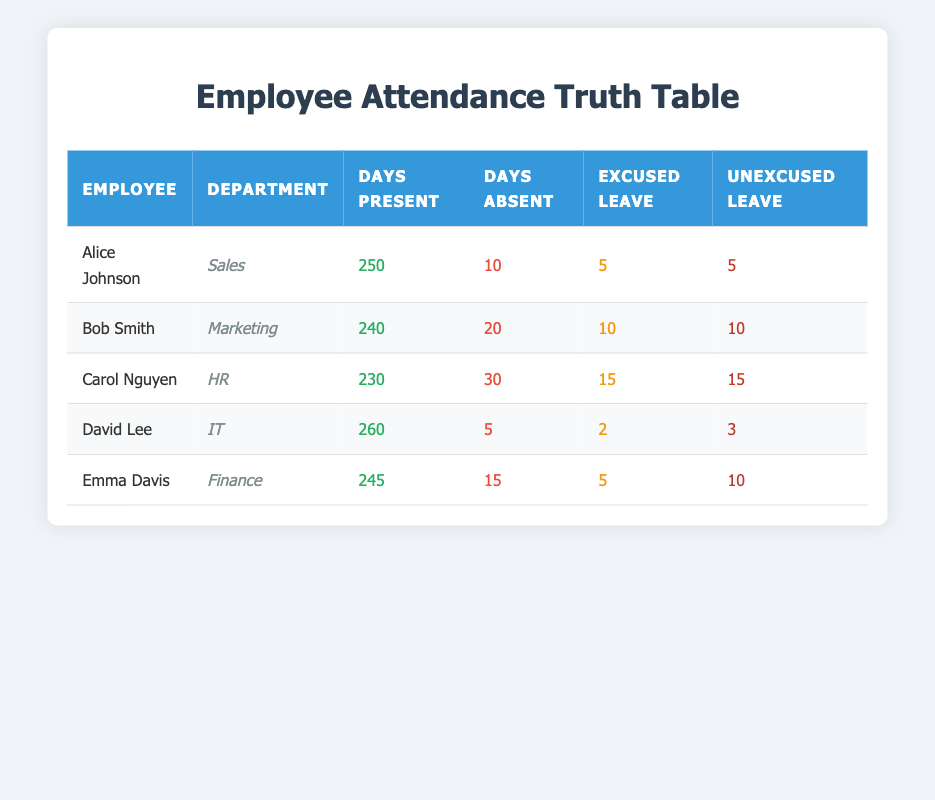What is the total number of days absent for Alice Johnson? Alice Johnson has 10 days absent in total as shown in the attendance section of her record in the table.
Answer: 10 Which employee has the highest number of days present? David Lee has the highest number of days present, which is 260, as indicated in the "Days Present" column.
Answer: David Lee What is the average number of excused leaves among all employees? The total excused leaves are (5 + 10 + 15 + 2 + 5) = 37. There are 5 employees, so the average is 37/5 = 7.4.
Answer: 7.4 Did Carol Nguyen take more unexcused leaves than Emma Davis? Carol Nguyen took 15 unexcused leaves, while Emma Davis took 10. Since 15 is greater than 10, the statement is true.
Answer: Yes How many days absent are there in total across all employees? Summing the days absent gives (10 + 20 + 30 + 5 + 15) = 80 days.
Answer: 80 What percentage of days present does Bob Smith have compared to the maximum present days of 260? Bob Smith has 240 days present. The percentage is (240/260) * 100 = 92.31%.
Answer: 92.31% Who has the lowest number of days present? Carol Nguyen has the lowest number of days present at 230, which is detailed in the "Days Present" column.
Answer: Carol Nguyen Is there an employee who was present for at least 250 days? Both Alice Johnson (250 days) and David Lee (260 days) were present for at least 250 days, so the statement is true as both meet the criteria.
Answer: Yes What is the difference in excused leaves between Bob Smith and David Lee? Bob Smith has 10 excused leaves, while David Lee has 2 excused leaves. The difference is 10 - 2 = 8.
Answer: 8 